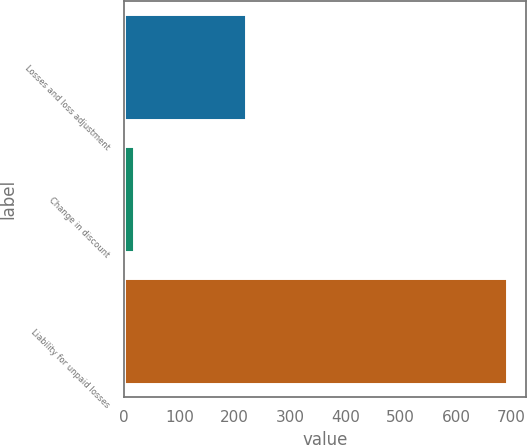<chart> <loc_0><loc_0><loc_500><loc_500><bar_chart><fcel>Losses and loss adjustment<fcel>Change in discount<fcel>Liability for unpaid losses<nl><fcel>220.2<fcel>18<fcel>692<nl></chart> 